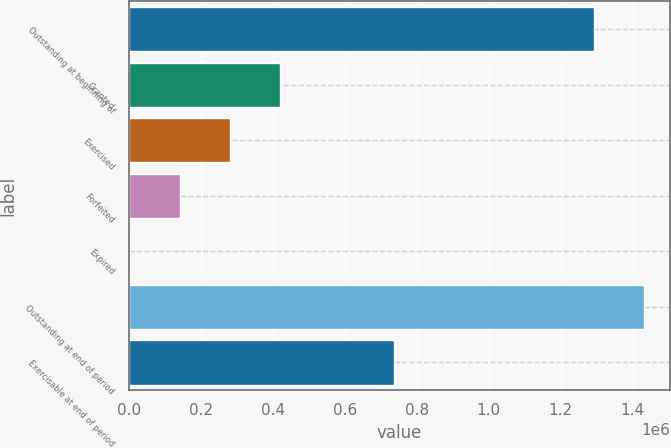<chart> <loc_0><loc_0><loc_500><loc_500><bar_chart><fcel>Outstanding at beginning of<fcel>Granted<fcel>Exercised<fcel>Forfeited<fcel>Expired<fcel>Outstanding at end of period<fcel>Exercisable at end of period<nl><fcel>1.29214e+06<fcel>420366<fcel>280760<fcel>141153<fcel>1547<fcel>1.43175e+06<fcel>736075<nl></chart> 